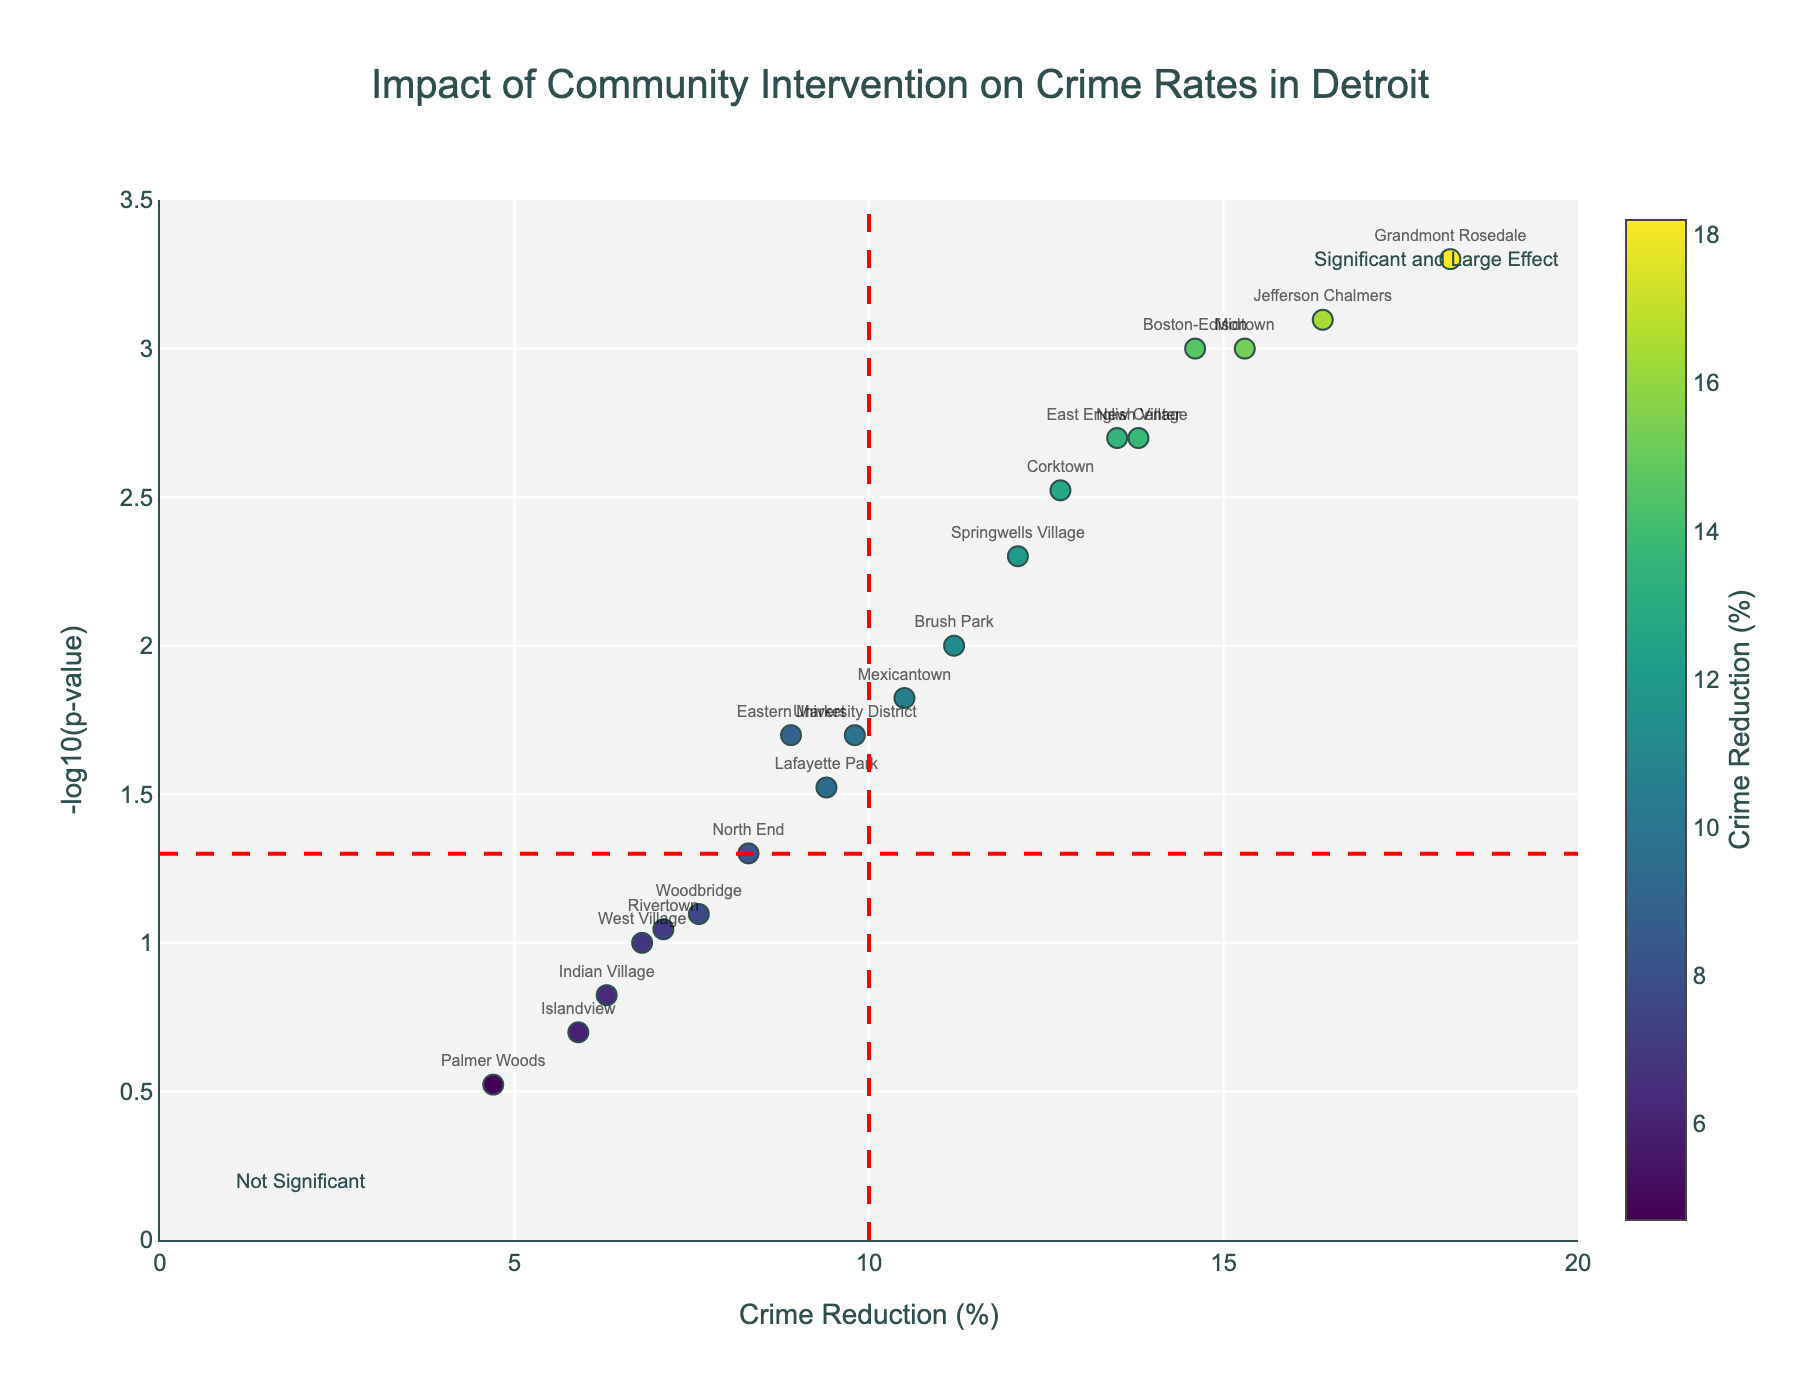What is the title of the figure? The title of the figure is positioned at the top. It reads "Impact of Community Intervention on Crime Rates in Detroit".
Answer: Impact of Community Intervention on Crime Rates in Detroit What are the axes labeled in the figure? The x-axis represents "Crime Reduction (%)", and the y-axis represents "-log10(p-value)". These labels are found along their respective axes.
Answer: Crime Reduction (%) and -log10(p-value) Which neighborhood experienced the highest percentage reduction in crime rate? The data point that is the farthest to the right on the x-axis shows the highest crime reduction percentage. Grandmont Rosedale has the highest value at 18.2%.
Answer: Grandmont Rosedale Which two neighborhoods are labeled closest to the "Not Significant" annotation? The "Not Significant" annotation is near the bottom left corner of the plot. Islandview and Palmer Woods are the closest neighborhoods to this annotation.
Answer: Islandview and Palmer Woods What does the red dashed line at x=10 indicate? The red dashed line at x=10 on the x-axis indicates a threshold for a large effect in crime reduction percentage. Neighborhoods to the right have reductions greater than 10%.
Answer: Large effect threshold How many neighborhoods have a significant reduction in crime rates (p-value < 0.05)? A significant reduction in crime rates is indicated by a p-value less than 0.05. This corresponds to -log10(p-value) greater than approximately 1.3. There are 12 neighborhoods above this value.
Answer: 12 Which neighborhood has the lowest crime reduction percentage but still has a statistically significant effect? The neighborhood with the lowest crime reduction percentage but still statistically significant will be the closest point to the left that is above the red dashed line at -log10(p) = 1.3. University District has a reduction of 9.8% and is above this line.
Answer: University District Compare the p-values of Grandmont Rosedale and Jefferson Chalmers. Which is more significant? The p-values can be compared directly using the y-axis values (-log10(p)). Grandmont Rosedale has a higher -log10(p-value) than Jefferson Chalmers, indicating it has a more significant p-value.
Answer: Grandmont Rosedale What area represents the combination of a significant and large effect? The combination of significant and large effects is represented in the upper right quadrant of the plot, beyond the red dashed lines at x=10 and -log10(p)=1.3.
Answer: Upper right quadrant Which neighborhood has a similar crime reduction percentage to Corktown but has a more significant p-value? By comparing the data points near Corktown's horizontal position (12.7% reduction), Eastern Market has a similar reduction (8.9%) but a lower p-value (more significant) as it is positioned higher on the y-axis.
Answer: Eastern Market 